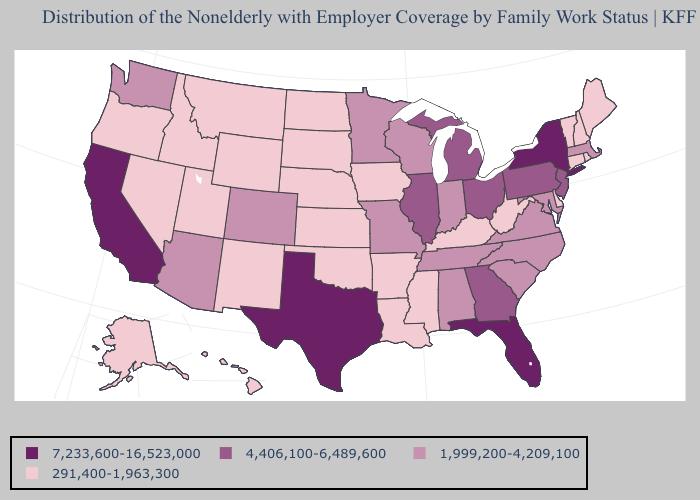Among the states that border Mississippi , does Arkansas have the lowest value?
Keep it brief. Yes. Which states hav the highest value in the South?
Keep it brief. Florida, Texas. What is the value of Connecticut?
Short answer required. 291,400-1,963,300. Name the states that have a value in the range 291,400-1,963,300?
Keep it brief. Alaska, Arkansas, Connecticut, Delaware, Hawaii, Idaho, Iowa, Kansas, Kentucky, Louisiana, Maine, Mississippi, Montana, Nebraska, Nevada, New Hampshire, New Mexico, North Dakota, Oklahoma, Oregon, Rhode Island, South Dakota, Utah, Vermont, West Virginia, Wyoming. Does the first symbol in the legend represent the smallest category?
Write a very short answer. No. Name the states that have a value in the range 7,233,600-16,523,000?
Concise answer only. California, Florida, New York, Texas. Does Virginia have the highest value in the USA?
Keep it brief. No. What is the value of North Dakota?
Give a very brief answer. 291,400-1,963,300. Does Illinois have the highest value in the MidWest?
Concise answer only. Yes. Name the states that have a value in the range 1,999,200-4,209,100?
Quick response, please. Alabama, Arizona, Colorado, Indiana, Maryland, Massachusetts, Minnesota, Missouri, North Carolina, South Carolina, Tennessee, Virginia, Washington, Wisconsin. What is the value of Washington?
Short answer required. 1,999,200-4,209,100. Is the legend a continuous bar?
Be succinct. No. Does Illinois have the highest value in the MidWest?
Keep it brief. Yes. Does Kansas have the same value as New Jersey?
Short answer required. No. What is the value of Georgia?
Concise answer only. 4,406,100-6,489,600. 